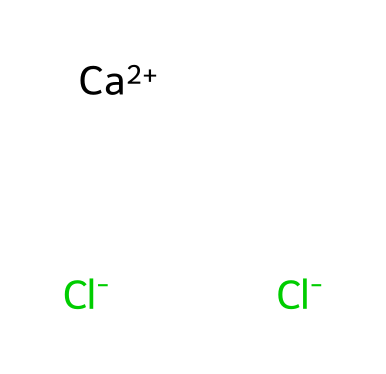What is the chemical name of this structure? The given SMILES notation corresponds to calcium ions (Ca) and two chloride ions (Cl), which together form calcium chloride.
Answer: calcium chloride How many total atoms are in this chemical structure? In the SMILES representation, there are one calcium atom and two chlorine atoms, totaling three atoms.
Answer: three How many chloride ions are present in this ionic compound? The SMILES shows two instances of chloride ions (Cl), indicating that there are two chloride ions present.
Answer: two Is calcium chloride an electrolyte? Calcium chloride dissociates into calcium and chloride ions in solution, which allows it to conduct electricity, making it an electrolyte.
Answer: yes What is the charge of a calcium ion in this structure? The representation indicates a calcium ion with a charge of +2, as denoted by [Ca+2].
Answer: +2 What effect does calcium chloride have on melting ice? Calcium chloride lowers the freezing point of water when applied, effectively melting ice and snow on construction sites.
Answer: melts ice How many bonds are likely present in this structure? The calcium ion interacts with two chloride ions, forming ionic bonds. Since ionic compounds do not have classic covalent bonds, we consider the ionic interactions rather than covalent bonds.
Answer: two ionic bonds 